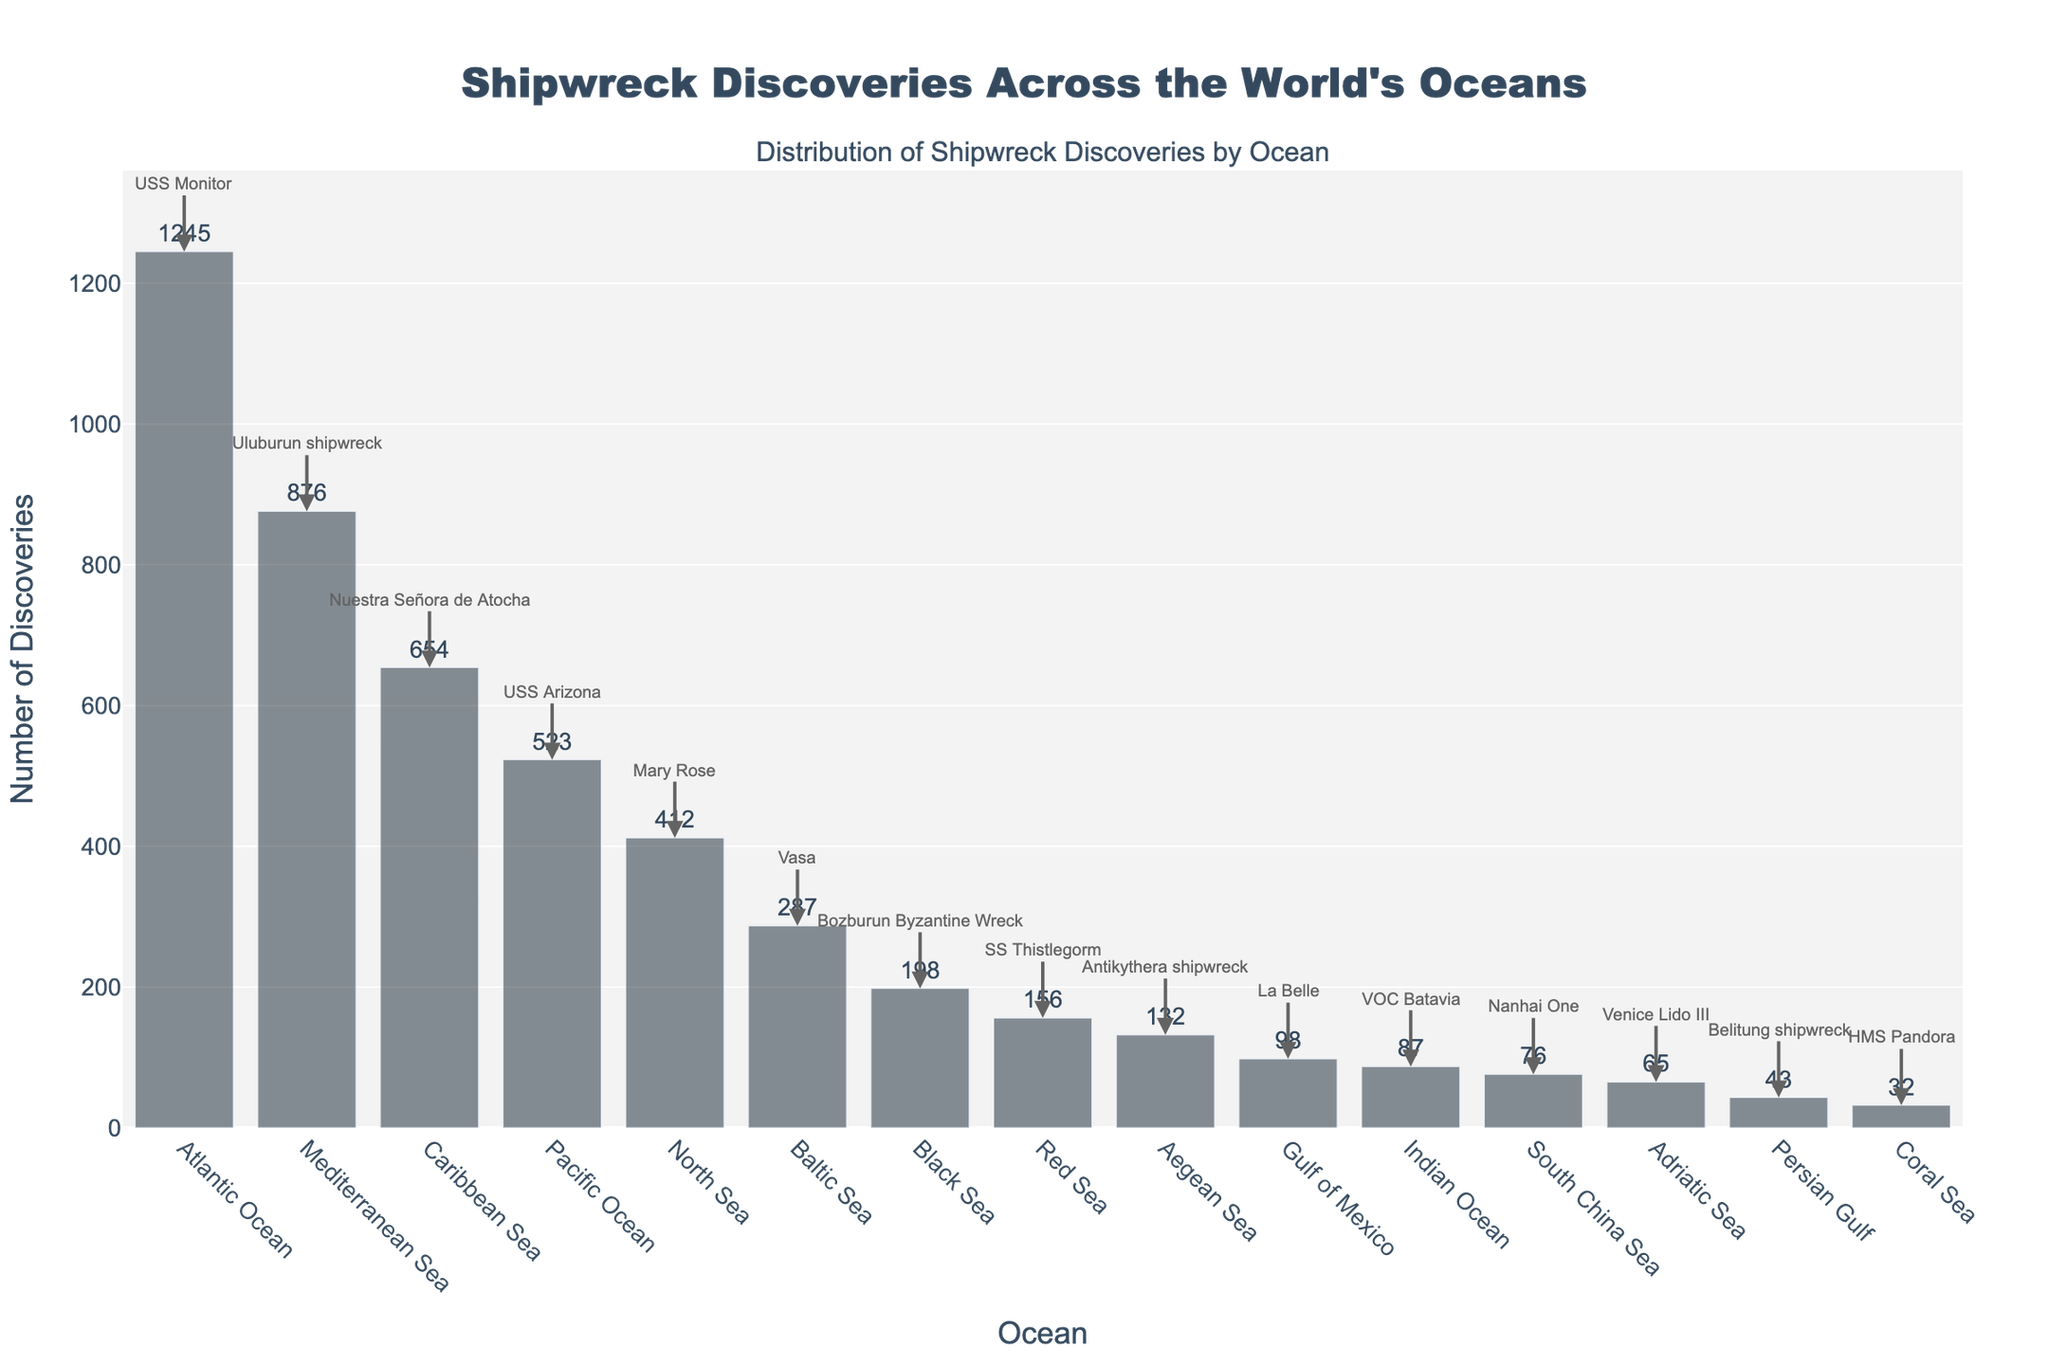Which ocean has the greatest number of shipwreck discoveries? By observing the height of the bars representing total discoveries, the Atlantic Ocean has the tallest bar, indicating the greatest number of shipwreck discoveries.
Answer: Atlantic Ocean Which ocean has more shipwreck discoveries, the Black Sea or the Red Sea? By comparing the heights of the bars for the Black Sea and the Red Sea, the bar for the Black Sea is taller, indicating a higher number of shipwreck discoveries.
Answer: Black Sea What's the average number of shipwreck discoveries across all oceans? To find the average, sum up the total discoveries: (1245 + 876 + 654 + 523 + 412 + 287 + 198 + 156 + 132 + 98 + 87 + 76 + 65 + 43 + 32) = 4900. Divide 4900 by the number of oceans (15).
Answer: 326.67 Which ocean has the least number of shipwreck discoveries, and what is the major find there? By identifying the shortest bar, the Coral Sea has the least number of shipwreck discoveries. The annotation indicates the major find there is the HMS Pandora.
Answer: Coral Sea, HMS Pandora How many more shipwreck discoveries are there in the Caribbean Sea compared to the Gulf of Mexico? Subtract the total discoveries for the Gulf of Mexico from those for the Caribbean Sea: 654 - 98 = 556.
Answer: 556 Which two oceans have the closest number of shipwreck discoveries, and what are their major finds? By examining the bars, the Black Sea (198) and Red Sea (156) have relatively close numbers of discoveries. Their major finds are the Bozburun Byzantine Wreck and SS Thistlegorm, respectively.
Answer: Black Sea, Red Sea; Bozburun Byzantine Wreck, SS Thistlegorm What is the total number of major finds highlighted in the figure? Each ocean has one major find, and with 15 oceans on the chart, there are a total of 15 major finds.
Answer: 15 How does the number of shipwreck discoveries in the Pacific Ocean compare to those in the Mediterranean Sea? By comparing the bars, the Mediterranean Sea (876) has more shipwreck discoveries than the Pacific Ocean (523).
Answer: Mediterranean Sea What percentage of the total shipwreck discoveries does the Atlantic Ocean represent? First, divide the total discoveries in the Atlantic Ocean by the total number of discoveries across all oceans, then multiply by 100: (1245 / 4900) * 100 ≈ 25.41%.
Answer: 25.41% What ocean hosts the USS Arizona and how many total shipwreck discoveries are there in that ocean? By looking at the annotations, the USS Arizona is listed in the Pacific Ocean, which has a total of 523 shipwreck discoveries.
Answer: Pacific Ocean, 523 